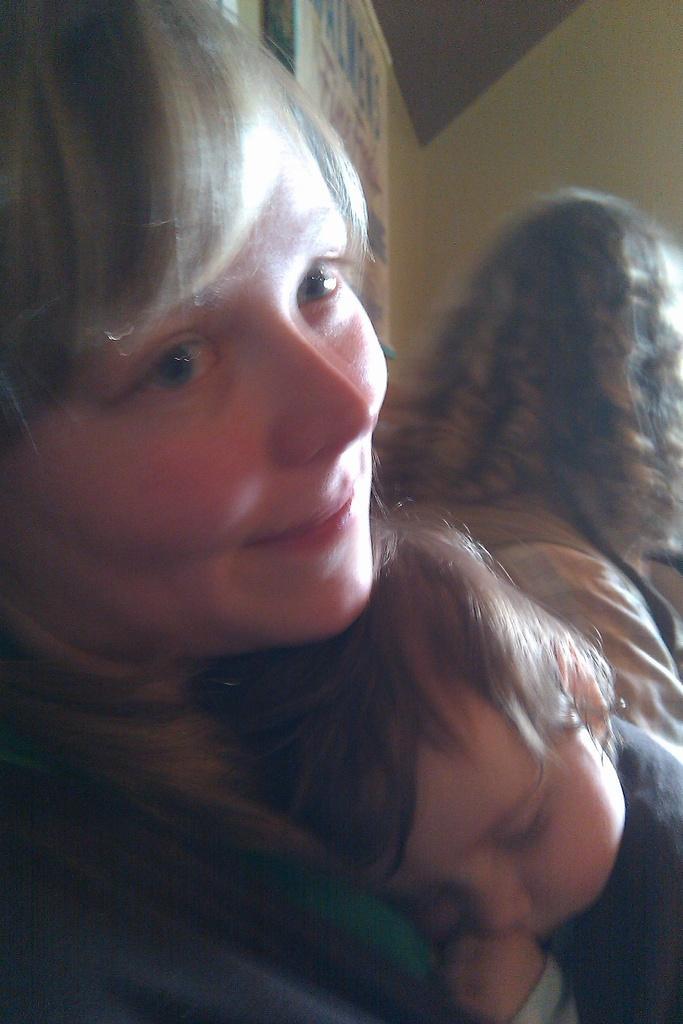Describe this image in one or two sentences. In this image in the foreground there is one person who is holding a baby and beside her there is another woman who is sitting. In the background there are some boards on the wall. 